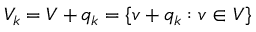<formula> <loc_0><loc_0><loc_500><loc_500>V _ { k } = V + q _ { k } = \{ v + q _ { k } \colon v \in V \}</formula> 